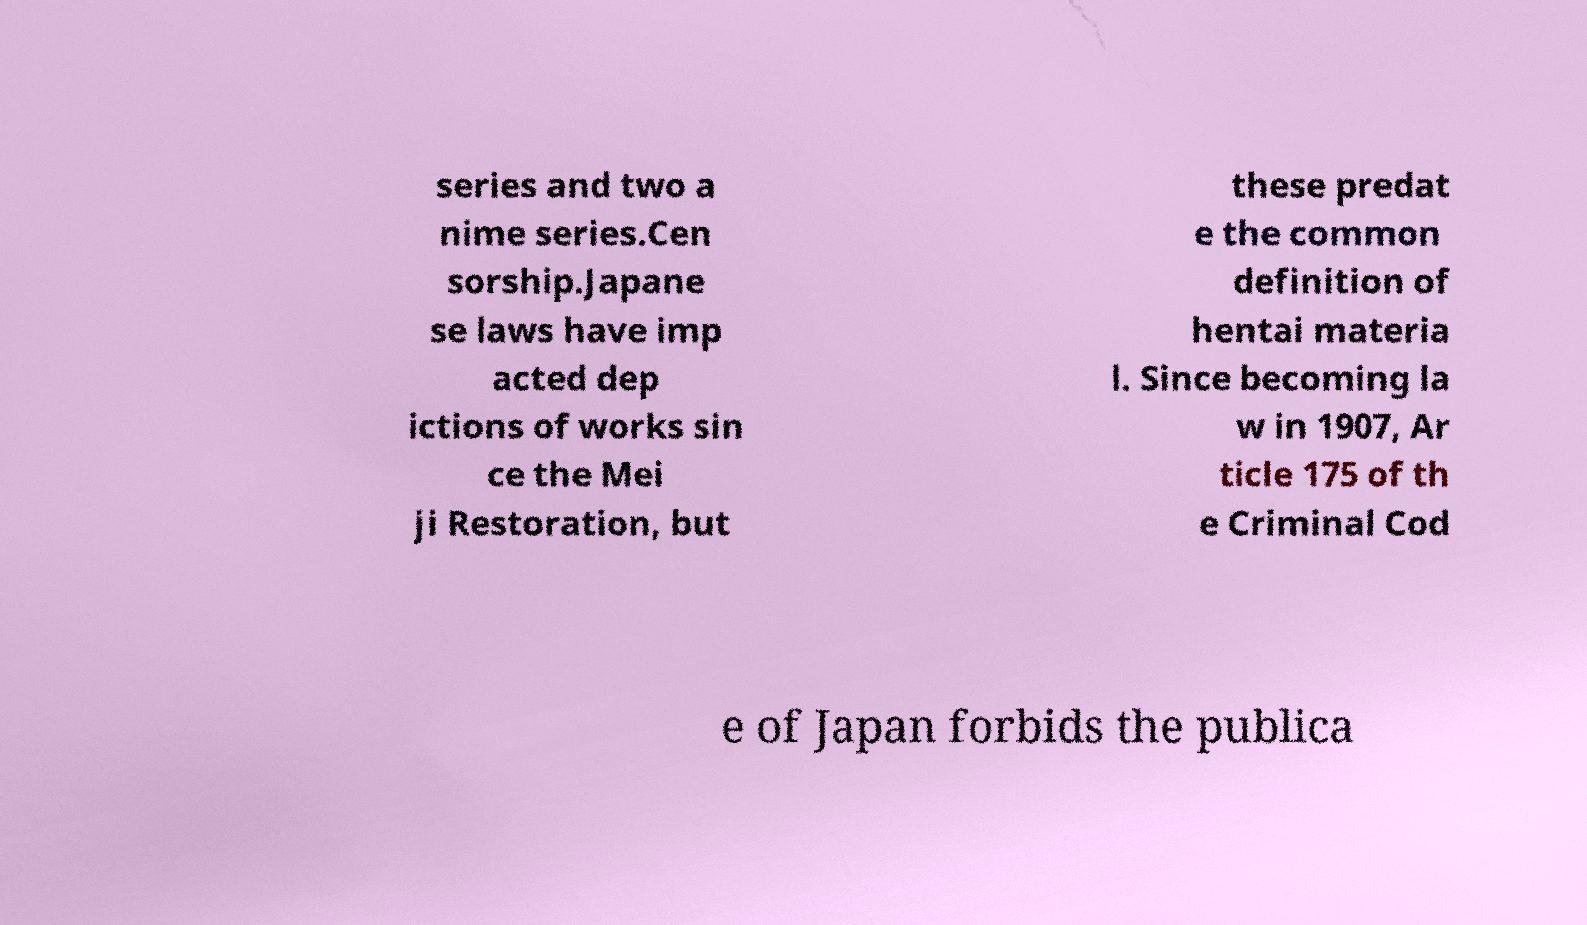Please identify and transcribe the text found in this image. series and two a nime series.Cen sorship.Japane se laws have imp acted dep ictions of works sin ce the Mei ji Restoration, but these predat e the common definition of hentai materia l. Since becoming la w in 1907, Ar ticle 175 of th e Criminal Cod e of Japan forbids the publica 